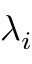<formula> <loc_0><loc_0><loc_500><loc_500>\lambda _ { i }</formula> 